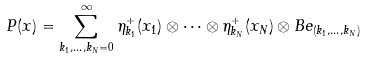<formula> <loc_0><loc_0><loc_500><loc_500>P ( x ) = \sum _ { k _ { 1 } , \dots , k _ { N } = 0 } ^ { \infty } \eta _ { k _ { 1 } } ^ { + } ( x _ { 1 } ) \otimes \cdots \otimes \eta _ { k _ { N } } ^ { + } ( x _ { N } ) \otimes B e _ { ( k _ { 1 } , \dots , k _ { N } ) }</formula> 